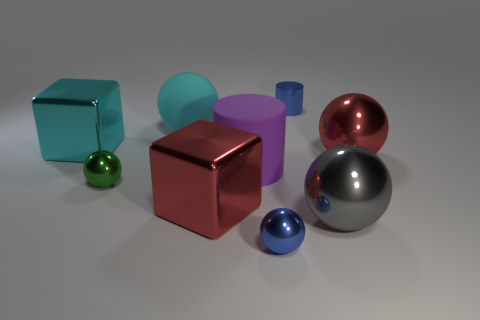There is a cylinder that is in front of the cylinder to the right of the small metal sphere right of the large purple matte object; what color is it?
Your response must be concise. Purple. There is a cylinder that is the same size as the cyan matte ball; what is it made of?
Provide a succinct answer. Rubber. How many gray balls are the same material as the tiny cylinder?
Offer a very short reply. 1. There is a metallic cube to the right of the cyan sphere; is its size the same as the cube to the left of the tiny green shiny ball?
Give a very brief answer. Yes. There is a large cube behind the large purple rubber cylinder; what is its color?
Make the answer very short. Cyan. There is a tiny sphere that is the same color as the small cylinder; what is it made of?
Offer a terse response. Metal. How many metal blocks have the same color as the big matte sphere?
Keep it short and to the point. 1. There is a purple rubber cylinder; does it have the same size as the red metallic object on the right side of the small blue cylinder?
Provide a succinct answer. Yes. There is a cyan block on the left side of the rubber object on the left side of the red object that is on the left side of the large red ball; what size is it?
Make the answer very short. Large. There is a cyan matte object; how many metal balls are to the left of it?
Provide a short and direct response. 1. 